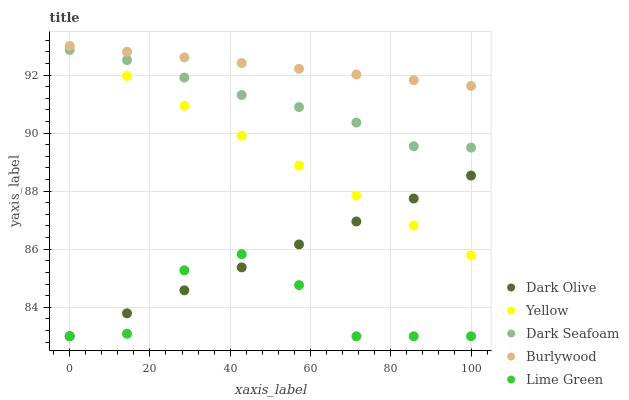Does Lime Green have the minimum area under the curve?
Answer yes or no. Yes. Does Burlywood have the maximum area under the curve?
Answer yes or no. Yes. Does Dark Seafoam have the minimum area under the curve?
Answer yes or no. No. Does Dark Seafoam have the maximum area under the curve?
Answer yes or no. No. Is Yellow the smoothest?
Answer yes or no. Yes. Is Lime Green the roughest?
Answer yes or no. Yes. Is Dark Seafoam the smoothest?
Answer yes or no. No. Is Dark Seafoam the roughest?
Answer yes or no. No. Does Dark Olive have the lowest value?
Answer yes or no. Yes. Does Dark Seafoam have the lowest value?
Answer yes or no. No. Does Yellow have the highest value?
Answer yes or no. Yes. Does Dark Seafoam have the highest value?
Answer yes or no. No. Is Lime Green less than Burlywood?
Answer yes or no. Yes. Is Dark Seafoam greater than Lime Green?
Answer yes or no. Yes. Does Lime Green intersect Dark Olive?
Answer yes or no. Yes. Is Lime Green less than Dark Olive?
Answer yes or no. No. Is Lime Green greater than Dark Olive?
Answer yes or no. No. Does Lime Green intersect Burlywood?
Answer yes or no. No. 